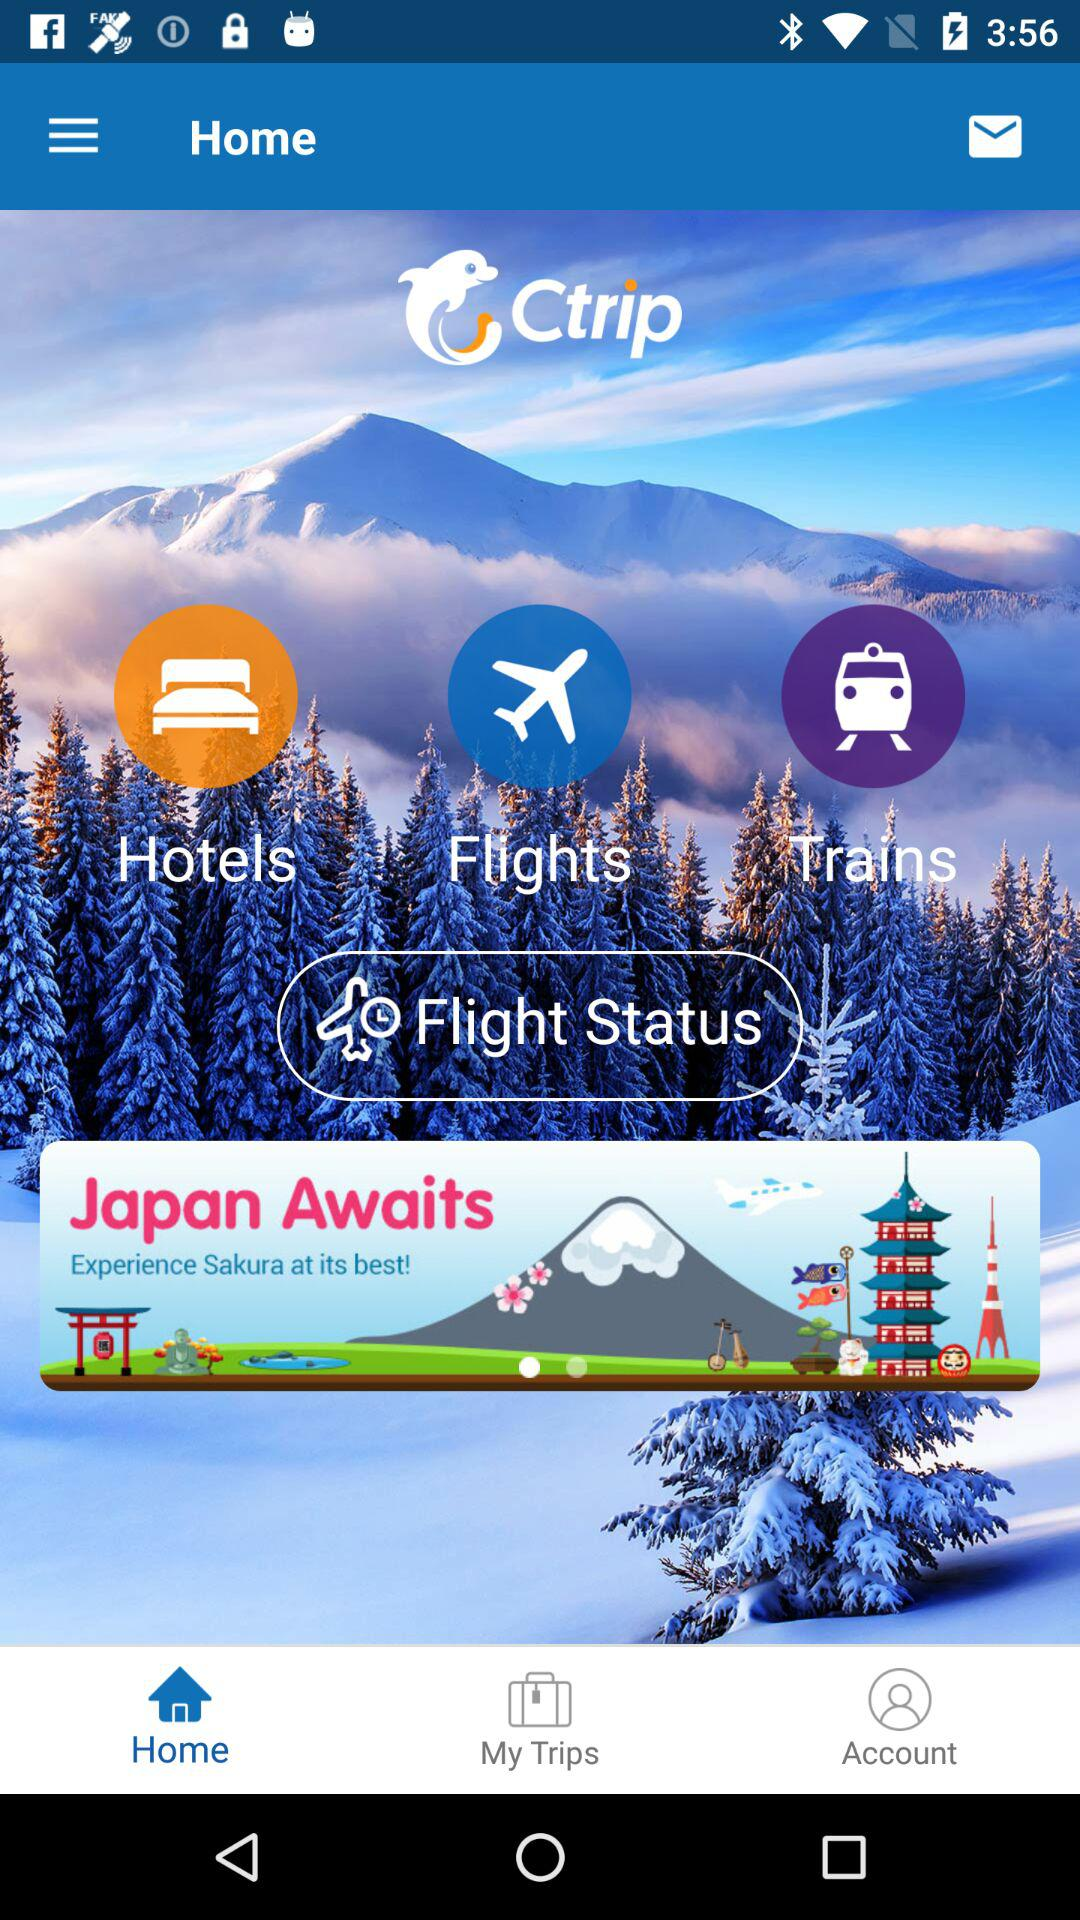What is the application name? The application name is "Ctrip". 